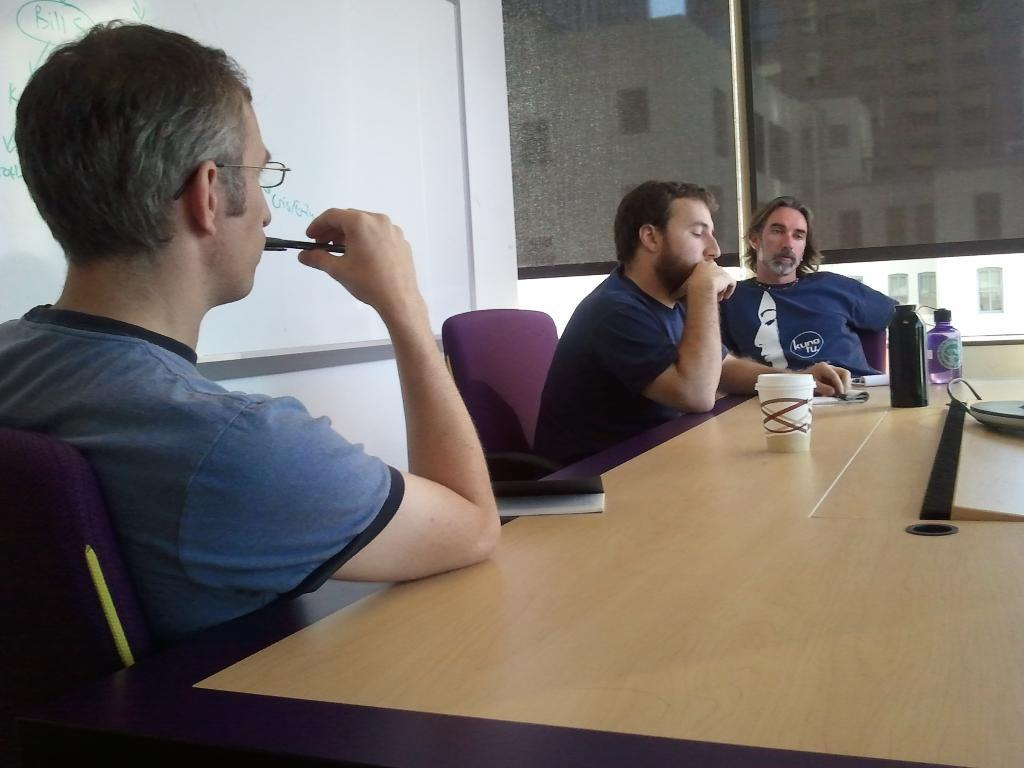How many people are in the image? There are three men in the image. What are the men doing in the image? The men are sitting on chairs in the image. What is present in the image besides the men? There is a table in the image. What items can be seen on the table? There are bottles and a cup on the table. How does the force of gravity affect the men's faces in the image? The image does not provide information about the force of gravity affecting the men's faces, as it is a static image. 